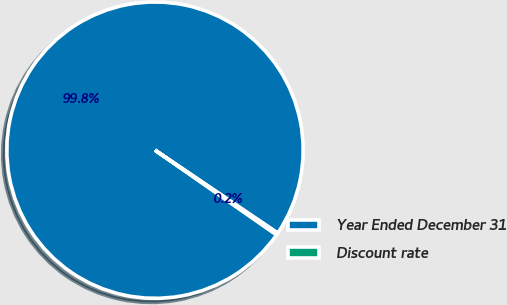Convert chart to OTSL. <chart><loc_0><loc_0><loc_500><loc_500><pie_chart><fcel>Year Ended December 31<fcel>Discount rate<nl><fcel>99.78%<fcel>0.22%<nl></chart> 